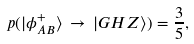<formula> <loc_0><loc_0><loc_500><loc_500>p ( | \phi ^ { + } _ { A B } \rangle \, \rightarrow \, | G H Z \rangle ) = \frac { 3 } { 5 } ,</formula> 